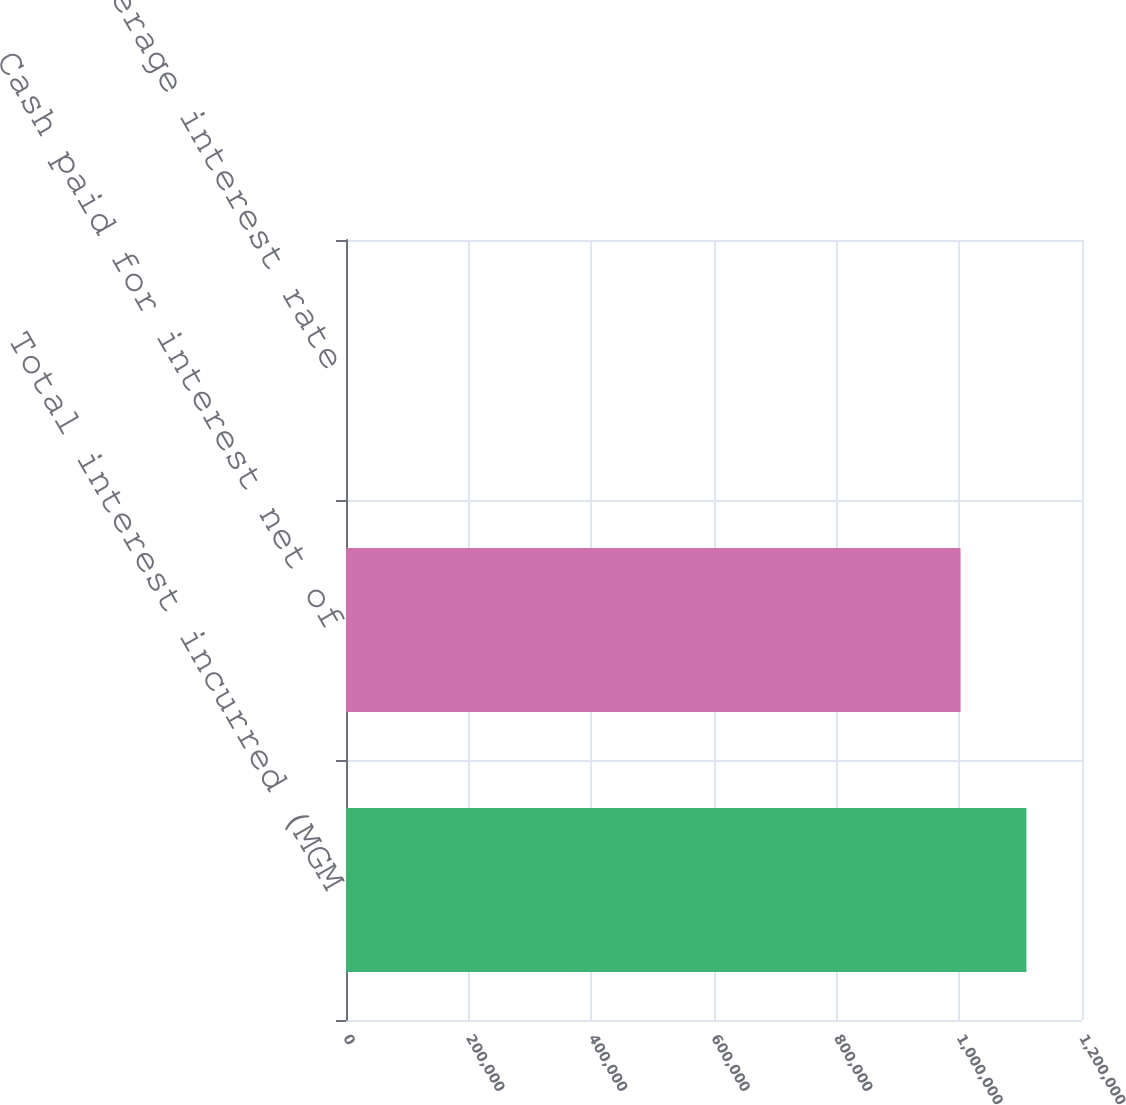Convert chart to OTSL. <chart><loc_0><loc_0><loc_500><loc_500><bar_chart><fcel>Total interest incurred (MGM<fcel>Cash paid for interest net of<fcel>Weighted average interest rate<nl><fcel>1.10938e+06<fcel>1.00198e+06<fcel>7.7<nl></chart> 